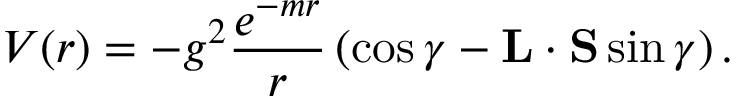Convert formula to latex. <formula><loc_0><loc_0><loc_500><loc_500>V ( r ) = - g ^ { 2 } \frac { e ^ { - m r } } { r } \left ( \cos \gamma - { L } \cdot { S } \sin \gamma \right ) .</formula> 